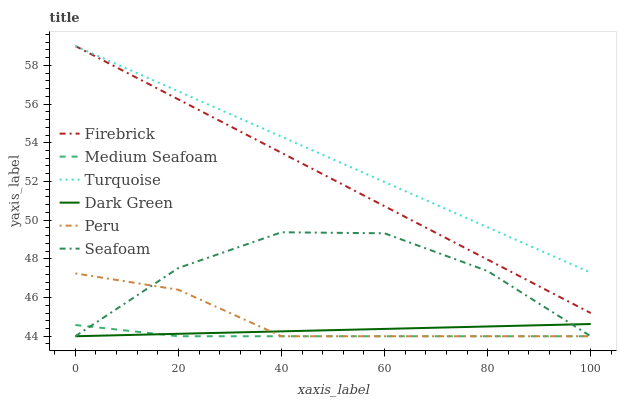Does Firebrick have the minimum area under the curve?
Answer yes or no. No. Does Firebrick have the maximum area under the curve?
Answer yes or no. No. Is Firebrick the smoothest?
Answer yes or no. No. Is Firebrick the roughest?
Answer yes or no. No. Does Firebrick have the lowest value?
Answer yes or no. No. Does Seafoam have the highest value?
Answer yes or no. No. Is Medium Seafoam less than Firebrick?
Answer yes or no. Yes. Is Firebrick greater than Seafoam?
Answer yes or no. Yes. Does Medium Seafoam intersect Firebrick?
Answer yes or no. No. 